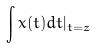Convert formula to latex. <formula><loc_0><loc_0><loc_500><loc_500>\int x ( t ) d t | _ { t = z }</formula> 